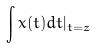Convert formula to latex. <formula><loc_0><loc_0><loc_500><loc_500>\int x ( t ) d t | _ { t = z }</formula> 